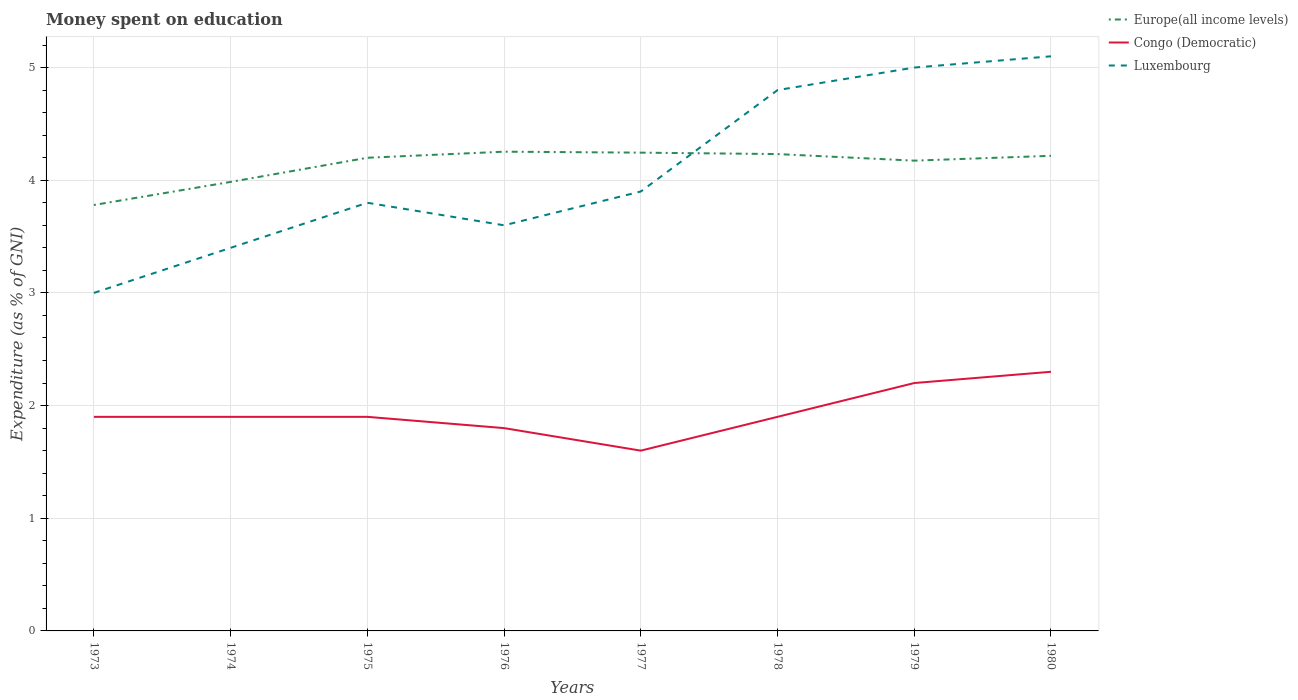Across all years, what is the maximum amount of money spent on education in Europe(all income levels)?
Provide a short and direct response. 3.78. What is the total amount of money spent on education in Congo (Democratic) in the graph?
Make the answer very short. -0.1. What is the difference between the highest and the second highest amount of money spent on education in Luxembourg?
Give a very brief answer. 2.1. Is the amount of money spent on education in Congo (Democratic) strictly greater than the amount of money spent on education in Europe(all income levels) over the years?
Offer a very short reply. Yes. How many years are there in the graph?
Your answer should be compact. 8. What is the difference between two consecutive major ticks on the Y-axis?
Your response must be concise. 1. Does the graph contain grids?
Your response must be concise. Yes. Where does the legend appear in the graph?
Your answer should be compact. Top right. How many legend labels are there?
Your response must be concise. 3. How are the legend labels stacked?
Your answer should be very brief. Vertical. What is the title of the graph?
Your answer should be very brief. Money spent on education. What is the label or title of the Y-axis?
Offer a terse response. Expenditure (as % of GNI). What is the Expenditure (as % of GNI) of Europe(all income levels) in 1973?
Provide a succinct answer. 3.78. What is the Expenditure (as % of GNI) in Luxembourg in 1973?
Provide a succinct answer. 3. What is the Expenditure (as % of GNI) of Europe(all income levels) in 1974?
Offer a very short reply. 3.99. What is the Expenditure (as % of GNI) in Congo (Democratic) in 1974?
Give a very brief answer. 1.9. What is the Expenditure (as % of GNI) of Luxembourg in 1974?
Provide a succinct answer. 3.4. What is the Expenditure (as % of GNI) in Europe(all income levels) in 1975?
Offer a very short reply. 4.2. What is the Expenditure (as % of GNI) in Congo (Democratic) in 1975?
Ensure brevity in your answer.  1.9. What is the Expenditure (as % of GNI) of Europe(all income levels) in 1976?
Offer a very short reply. 4.25. What is the Expenditure (as % of GNI) of Luxembourg in 1976?
Give a very brief answer. 3.6. What is the Expenditure (as % of GNI) of Europe(all income levels) in 1977?
Your response must be concise. 4.24. What is the Expenditure (as % of GNI) of Congo (Democratic) in 1977?
Your response must be concise. 1.6. What is the Expenditure (as % of GNI) in Luxembourg in 1977?
Offer a very short reply. 3.9. What is the Expenditure (as % of GNI) of Europe(all income levels) in 1978?
Offer a very short reply. 4.23. What is the Expenditure (as % of GNI) of Congo (Democratic) in 1978?
Offer a very short reply. 1.9. What is the Expenditure (as % of GNI) in Luxembourg in 1978?
Offer a very short reply. 4.8. What is the Expenditure (as % of GNI) of Europe(all income levels) in 1979?
Your response must be concise. 4.17. What is the Expenditure (as % of GNI) of Congo (Democratic) in 1979?
Make the answer very short. 2.2. What is the Expenditure (as % of GNI) of Europe(all income levels) in 1980?
Your response must be concise. 4.22. What is the Expenditure (as % of GNI) of Luxembourg in 1980?
Provide a succinct answer. 5.1. Across all years, what is the maximum Expenditure (as % of GNI) of Europe(all income levels)?
Make the answer very short. 4.25. Across all years, what is the minimum Expenditure (as % of GNI) of Europe(all income levels)?
Your answer should be very brief. 3.78. Across all years, what is the minimum Expenditure (as % of GNI) of Congo (Democratic)?
Offer a terse response. 1.6. Across all years, what is the minimum Expenditure (as % of GNI) of Luxembourg?
Offer a terse response. 3. What is the total Expenditure (as % of GNI) of Europe(all income levels) in the graph?
Keep it short and to the point. 33.09. What is the total Expenditure (as % of GNI) of Congo (Democratic) in the graph?
Give a very brief answer. 15.5. What is the total Expenditure (as % of GNI) of Luxembourg in the graph?
Ensure brevity in your answer.  32.6. What is the difference between the Expenditure (as % of GNI) in Europe(all income levels) in 1973 and that in 1974?
Ensure brevity in your answer.  -0.2. What is the difference between the Expenditure (as % of GNI) of Congo (Democratic) in 1973 and that in 1974?
Your answer should be very brief. 0. What is the difference between the Expenditure (as % of GNI) in Europe(all income levels) in 1973 and that in 1975?
Keep it short and to the point. -0.42. What is the difference between the Expenditure (as % of GNI) of Congo (Democratic) in 1973 and that in 1975?
Your response must be concise. 0. What is the difference between the Expenditure (as % of GNI) in Europe(all income levels) in 1973 and that in 1976?
Ensure brevity in your answer.  -0.47. What is the difference between the Expenditure (as % of GNI) of Europe(all income levels) in 1973 and that in 1977?
Provide a short and direct response. -0.46. What is the difference between the Expenditure (as % of GNI) in Congo (Democratic) in 1973 and that in 1977?
Ensure brevity in your answer.  0.3. What is the difference between the Expenditure (as % of GNI) of Luxembourg in 1973 and that in 1977?
Provide a succinct answer. -0.9. What is the difference between the Expenditure (as % of GNI) of Europe(all income levels) in 1973 and that in 1978?
Your answer should be very brief. -0.45. What is the difference between the Expenditure (as % of GNI) in Congo (Democratic) in 1973 and that in 1978?
Your answer should be very brief. 0. What is the difference between the Expenditure (as % of GNI) of Europe(all income levels) in 1973 and that in 1979?
Your response must be concise. -0.39. What is the difference between the Expenditure (as % of GNI) of Luxembourg in 1973 and that in 1979?
Your answer should be compact. -2. What is the difference between the Expenditure (as % of GNI) in Europe(all income levels) in 1973 and that in 1980?
Your answer should be compact. -0.44. What is the difference between the Expenditure (as % of GNI) of Europe(all income levels) in 1974 and that in 1975?
Your response must be concise. -0.21. What is the difference between the Expenditure (as % of GNI) of Congo (Democratic) in 1974 and that in 1975?
Provide a succinct answer. 0. What is the difference between the Expenditure (as % of GNI) in Europe(all income levels) in 1974 and that in 1976?
Provide a short and direct response. -0.27. What is the difference between the Expenditure (as % of GNI) in Congo (Democratic) in 1974 and that in 1976?
Keep it short and to the point. 0.1. What is the difference between the Expenditure (as % of GNI) of Luxembourg in 1974 and that in 1976?
Offer a very short reply. -0.2. What is the difference between the Expenditure (as % of GNI) in Europe(all income levels) in 1974 and that in 1977?
Your answer should be very brief. -0.26. What is the difference between the Expenditure (as % of GNI) in Europe(all income levels) in 1974 and that in 1978?
Keep it short and to the point. -0.25. What is the difference between the Expenditure (as % of GNI) in Luxembourg in 1974 and that in 1978?
Provide a short and direct response. -1.4. What is the difference between the Expenditure (as % of GNI) in Europe(all income levels) in 1974 and that in 1979?
Offer a terse response. -0.19. What is the difference between the Expenditure (as % of GNI) of Congo (Democratic) in 1974 and that in 1979?
Provide a short and direct response. -0.3. What is the difference between the Expenditure (as % of GNI) of Luxembourg in 1974 and that in 1979?
Provide a short and direct response. -1.6. What is the difference between the Expenditure (as % of GNI) in Europe(all income levels) in 1974 and that in 1980?
Give a very brief answer. -0.23. What is the difference between the Expenditure (as % of GNI) of Luxembourg in 1974 and that in 1980?
Give a very brief answer. -1.7. What is the difference between the Expenditure (as % of GNI) of Europe(all income levels) in 1975 and that in 1976?
Provide a short and direct response. -0.05. What is the difference between the Expenditure (as % of GNI) of Congo (Democratic) in 1975 and that in 1976?
Make the answer very short. 0.1. What is the difference between the Expenditure (as % of GNI) in Luxembourg in 1975 and that in 1976?
Keep it short and to the point. 0.2. What is the difference between the Expenditure (as % of GNI) in Europe(all income levels) in 1975 and that in 1977?
Provide a short and direct response. -0.05. What is the difference between the Expenditure (as % of GNI) in Europe(all income levels) in 1975 and that in 1978?
Keep it short and to the point. -0.03. What is the difference between the Expenditure (as % of GNI) of Congo (Democratic) in 1975 and that in 1978?
Your answer should be compact. 0. What is the difference between the Expenditure (as % of GNI) in Luxembourg in 1975 and that in 1978?
Keep it short and to the point. -1. What is the difference between the Expenditure (as % of GNI) of Europe(all income levels) in 1975 and that in 1979?
Provide a short and direct response. 0.03. What is the difference between the Expenditure (as % of GNI) in Europe(all income levels) in 1975 and that in 1980?
Your response must be concise. -0.02. What is the difference between the Expenditure (as % of GNI) of Europe(all income levels) in 1976 and that in 1977?
Give a very brief answer. 0.01. What is the difference between the Expenditure (as % of GNI) in Luxembourg in 1976 and that in 1977?
Your answer should be compact. -0.3. What is the difference between the Expenditure (as % of GNI) in Europe(all income levels) in 1976 and that in 1978?
Offer a very short reply. 0.02. What is the difference between the Expenditure (as % of GNI) of Europe(all income levels) in 1976 and that in 1979?
Your answer should be very brief. 0.08. What is the difference between the Expenditure (as % of GNI) of Luxembourg in 1976 and that in 1979?
Provide a short and direct response. -1.4. What is the difference between the Expenditure (as % of GNI) in Europe(all income levels) in 1976 and that in 1980?
Offer a very short reply. 0.04. What is the difference between the Expenditure (as % of GNI) in Europe(all income levels) in 1977 and that in 1978?
Provide a succinct answer. 0.01. What is the difference between the Expenditure (as % of GNI) of Congo (Democratic) in 1977 and that in 1978?
Make the answer very short. -0.3. What is the difference between the Expenditure (as % of GNI) of Luxembourg in 1977 and that in 1978?
Ensure brevity in your answer.  -0.9. What is the difference between the Expenditure (as % of GNI) in Europe(all income levels) in 1977 and that in 1979?
Your answer should be compact. 0.07. What is the difference between the Expenditure (as % of GNI) of Congo (Democratic) in 1977 and that in 1979?
Provide a succinct answer. -0.6. What is the difference between the Expenditure (as % of GNI) in Luxembourg in 1977 and that in 1979?
Your response must be concise. -1.1. What is the difference between the Expenditure (as % of GNI) in Europe(all income levels) in 1977 and that in 1980?
Offer a terse response. 0.03. What is the difference between the Expenditure (as % of GNI) in Europe(all income levels) in 1978 and that in 1979?
Provide a succinct answer. 0.06. What is the difference between the Expenditure (as % of GNI) in Luxembourg in 1978 and that in 1979?
Your answer should be very brief. -0.2. What is the difference between the Expenditure (as % of GNI) in Europe(all income levels) in 1978 and that in 1980?
Provide a short and direct response. 0.02. What is the difference between the Expenditure (as % of GNI) in Europe(all income levels) in 1979 and that in 1980?
Your answer should be very brief. -0.04. What is the difference between the Expenditure (as % of GNI) in Luxembourg in 1979 and that in 1980?
Your response must be concise. -0.1. What is the difference between the Expenditure (as % of GNI) of Europe(all income levels) in 1973 and the Expenditure (as % of GNI) of Congo (Democratic) in 1974?
Make the answer very short. 1.88. What is the difference between the Expenditure (as % of GNI) of Europe(all income levels) in 1973 and the Expenditure (as % of GNI) of Luxembourg in 1974?
Ensure brevity in your answer.  0.38. What is the difference between the Expenditure (as % of GNI) in Congo (Democratic) in 1973 and the Expenditure (as % of GNI) in Luxembourg in 1974?
Offer a very short reply. -1.5. What is the difference between the Expenditure (as % of GNI) of Europe(all income levels) in 1973 and the Expenditure (as % of GNI) of Congo (Democratic) in 1975?
Offer a very short reply. 1.88. What is the difference between the Expenditure (as % of GNI) in Europe(all income levels) in 1973 and the Expenditure (as % of GNI) in Luxembourg in 1975?
Give a very brief answer. -0.02. What is the difference between the Expenditure (as % of GNI) of Europe(all income levels) in 1973 and the Expenditure (as % of GNI) of Congo (Democratic) in 1976?
Make the answer very short. 1.98. What is the difference between the Expenditure (as % of GNI) in Europe(all income levels) in 1973 and the Expenditure (as % of GNI) in Luxembourg in 1976?
Keep it short and to the point. 0.18. What is the difference between the Expenditure (as % of GNI) in Europe(all income levels) in 1973 and the Expenditure (as % of GNI) in Congo (Democratic) in 1977?
Your answer should be compact. 2.18. What is the difference between the Expenditure (as % of GNI) of Europe(all income levels) in 1973 and the Expenditure (as % of GNI) of Luxembourg in 1977?
Provide a short and direct response. -0.12. What is the difference between the Expenditure (as % of GNI) in Congo (Democratic) in 1973 and the Expenditure (as % of GNI) in Luxembourg in 1977?
Offer a very short reply. -2. What is the difference between the Expenditure (as % of GNI) of Europe(all income levels) in 1973 and the Expenditure (as % of GNI) of Congo (Democratic) in 1978?
Ensure brevity in your answer.  1.88. What is the difference between the Expenditure (as % of GNI) of Europe(all income levels) in 1973 and the Expenditure (as % of GNI) of Luxembourg in 1978?
Give a very brief answer. -1.02. What is the difference between the Expenditure (as % of GNI) in Europe(all income levels) in 1973 and the Expenditure (as % of GNI) in Congo (Democratic) in 1979?
Provide a short and direct response. 1.58. What is the difference between the Expenditure (as % of GNI) in Europe(all income levels) in 1973 and the Expenditure (as % of GNI) in Luxembourg in 1979?
Make the answer very short. -1.22. What is the difference between the Expenditure (as % of GNI) in Europe(all income levels) in 1973 and the Expenditure (as % of GNI) in Congo (Democratic) in 1980?
Your answer should be compact. 1.48. What is the difference between the Expenditure (as % of GNI) of Europe(all income levels) in 1973 and the Expenditure (as % of GNI) of Luxembourg in 1980?
Provide a succinct answer. -1.32. What is the difference between the Expenditure (as % of GNI) of Congo (Democratic) in 1973 and the Expenditure (as % of GNI) of Luxembourg in 1980?
Offer a very short reply. -3.2. What is the difference between the Expenditure (as % of GNI) of Europe(all income levels) in 1974 and the Expenditure (as % of GNI) of Congo (Democratic) in 1975?
Provide a succinct answer. 2.09. What is the difference between the Expenditure (as % of GNI) in Europe(all income levels) in 1974 and the Expenditure (as % of GNI) in Luxembourg in 1975?
Make the answer very short. 0.19. What is the difference between the Expenditure (as % of GNI) of Europe(all income levels) in 1974 and the Expenditure (as % of GNI) of Congo (Democratic) in 1976?
Offer a terse response. 2.19. What is the difference between the Expenditure (as % of GNI) in Europe(all income levels) in 1974 and the Expenditure (as % of GNI) in Luxembourg in 1976?
Ensure brevity in your answer.  0.39. What is the difference between the Expenditure (as % of GNI) of Congo (Democratic) in 1974 and the Expenditure (as % of GNI) of Luxembourg in 1976?
Give a very brief answer. -1.7. What is the difference between the Expenditure (as % of GNI) in Europe(all income levels) in 1974 and the Expenditure (as % of GNI) in Congo (Democratic) in 1977?
Give a very brief answer. 2.39. What is the difference between the Expenditure (as % of GNI) of Europe(all income levels) in 1974 and the Expenditure (as % of GNI) of Luxembourg in 1977?
Offer a very short reply. 0.09. What is the difference between the Expenditure (as % of GNI) of Europe(all income levels) in 1974 and the Expenditure (as % of GNI) of Congo (Democratic) in 1978?
Make the answer very short. 2.09. What is the difference between the Expenditure (as % of GNI) of Europe(all income levels) in 1974 and the Expenditure (as % of GNI) of Luxembourg in 1978?
Your answer should be compact. -0.81. What is the difference between the Expenditure (as % of GNI) in Europe(all income levels) in 1974 and the Expenditure (as % of GNI) in Congo (Democratic) in 1979?
Keep it short and to the point. 1.79. What is the difference between the Expenditure (as % of GNI) of Europe(all income levels) in 1974 and the Expenditure (as % of GNI) of Luxembourg in 1979?
Provide a succinct answer. -1.01. What is the difference between the Expenditure (as % of GNI) in Europe(all income levels) in 1974 and the Expenditure (as % of GNI) in Congo (Democratic) in 1980?
Your answer should be very brief. 1.69. What is the difference between the Expenditure (as % of GNI) in Europe(all income levels) in 1974 and the Expenditure (as % of GNI) in Luxembourg in 1980?
Offer a terse response. -1.11. What is the difference between the Expenditure (as % of GNI) in Europe(all income levels) in 1975 and the Expenditure (as % of GNI) in Congo (Democratic) in 1976?
Give a very brief answer. 2.4. What is the difference between the Expenditure (as % of GNI) in Europe(all income levels) in 1975 and the Expenditure (as % of GNI) in Luxembourg in 1976?
Keep it short and to the point. 0.6. What is the difference between the Expenditure (as % of GNI) of Congo (Democratic) in 1975 and the Expenditure (as % of GNI) of Luxembourg in 1976?
Ensure brevity in your answer.  -1.7. What is the difference between the Expenditure (as % of GNI) of Europe(all income levels) in 1975 and the Expenditure (as % of GNI) of Congo (Democratic) in 1977?
Ensure brevity in your answer.  2.6. What is the difference between the Expenditure (as % of GNI) of Europe(all income levels) in 1975 and the Expenditure (as % of GNI) of Luxembourg in 1977?
Your response must be concise. 0.3. What is the difference between the Expenditure (as % of GNI) in Congo (Democratic) in 1975 and the Expenditure (as % of GNI) in Luxembourg in 1977?
Provide a short and direct response. -2. What is the difference between the Expenditure (as % of GNI) of Europe(all income levels) in 1975 and the Expenditure (as % of GNI) of Congo (Democratic) in 1978?
Your response must be concise. 2.3. What is the difference between the Expenditure (as % of GNI) in Europe(all income levels) in 1975 and the Expenditure (as % of GNI) in Luxembourg in 1978?
Provide a short and direct response. -0.6. What is the difference between the Expenditure (as % of GNI) in Congo (Democratic) in 1975 and the Expenditure (as % of GNI) in Luxembourg in 1978?
Your answer should be very brief. -2.9. What is the difference between the Expenditure (as % of GNI) in Europe(all income levels) in 1975 and the Expenditure (as % of GNI) in Congo (Democratic) in 1979?
Provide a short and direct response. 2. What is the difference between the Expenditure (as % of GNI) of Europe(all income levels) in 1975 and the Expenditure (as % of GNI) of Luxembourg in 1979?
Ensure brevity in your answer.  -0.8. What is the difference between the Expenditure (as % of GNI) in Europe(all income levels) in 1975 and the Expenditure (as % of GNI) in Congo (Democratic) in 1980?
Give a very brief answer. 1.9. What is the difference between the Expenditure (as % of GNI) in Europe(all income levels) in 1975 and the Expenditure (as % of GNI) in Luxembourg in 1980?
Give a very brief answer. -0.9. What is the difference between the Expenditure (as % of GNI) in Congo (Democratic) in 1975 and the Expenditure (as % of GNI) in Luxembourg in 1980?
Give a very brief answer. -3.2. What is the difference between the Expenditure (as % of GNI) of Europe(all income levels) in 1976 and the Expenditure (as % of GNI) of Congo (Democratic) in 1977?
Provide a succinct answer. 2.65. What is the difference between the Expenditure (as % of GNI) in Europe(all income levels) in 1976 and the Expenditure (as % of GNI) in Luxembourg in 1977?
Give a very brief answer. 0.35. What is the difference between the Expenditure (as % of GNI) of Europe(all income levels) in 1976 and the Expenditure (as % of GNI) of Congo (Democratic) in 1978?
Make the answer very short. 2.35. What is the difference between the Expenditure (as % of GNI) in Europe(all income levels) in 1976 and the Expenditure (as % of GNI) in Luxembourg in 1978?
Your response must be concise. -0.55. What is the difference between the Expenditure (as % of GNI) in Europe(all income levels) in 1976 and the Expenditure (as % of GNI) in Congo (Democratic) in 1979?
Your response must be concise. 2.05. What is the difference between the Expenditure (as % of GNI) in Europe(all income levels) in 1976 and the Expenditure (as % of GNI) in Luxembourg in 1979?
Provide a short and direct response. -0.75. What is the difference between the Expenditure (as % of GNI) in Congo (Democratic) in 1976 and the Expenditure (as % of GNI) in Luxembourg in 1979?
Your answer should be very brief. -3.2. What is the difference between the Expenditure (as % of GNI) of Europe(all income levels) in 1976 and the Expenditure (as % of GNI) of Congo (Democratic) in 1980?
Offer a very short reply. 1.95. What is the difference between the Expenditure (as % of GNI) in Europe(all income levels) in 1976 and the Expenditure (as % of GNI) in Luxembourg in 1980?
Keep it short and to the point. -0.85. What is the difference between the Expenditure (as % of GNI) in Congo (Democratic) in 1976 and the Expenditure (as % of GNI) in Luxembourg in 1980?
Your answer should be very brief. -3.3. What is the difference between the Expenditure (as % of GNI) of Europe(all income levels) in 1977 and the Expenditure (as % of GNI) of Congo (Democratic) in 1978?
Make the answer very short. 2.34. What is the difference between the Expenditure (as % of GNI) in Europe(all income levels) in 1977 and the Expenditure (as % of GNI) in Luxembourg in 1978?
Your response must be concise. -0.56. What is the difference between the Expenditure (as % of GNI) of Congo (Democratic) in 1977 and the Expenditure (as % of GNI) of Luxembourg in 1978?
Offer a terse response. -3.2. What is the difference between the Expenditure (as % of GNI) in Europe(all income levels) in 1977 and the Expenditure (as % of GNI) in Congo (Democratic) in 1979?
Offer a very short reply. 2.04. What is the difference between the Expenditure (as % of GNI) of Europe(all income levels) in 1977 and the Expenditure (as % of GNI) of Luxembourg in 1979?
Keep it short and to the point. -0.76. What is the difference between the Expenditure (as % of GNI) in Europe(all income levels) in 1977 and the Expenditure (as % of GNI) in Congo (Democratic) in 1980?
Make the answer very short. 1.94. What is the difference between the Expenditure (as % of GNI) in Europe(all income levels) in 1977 and the Expenditure (as % of GNI) in Luxembourg in 1980?
Your answer should be very brief. -0.86. What is the difference between the Expenditure (as % of GNI) of Europe(all income levels) in 1978 and the Expenditure (as % of GNI) of Congo (Democratic) in 1979?
Ensure brevity in your answer.  2.03. What is the difference between the Expenditure (as % of GNI) in Europe(all income levels) in 1978 and the Expenditure (as % of GNI) in Luxembourg in 1979?
Offer a terse response. -0.77. What is the difference between the Expenditure (as % of GNI) of Europe(all income levels) in 1978 and the Expenditure (as % of GNI) of Congo (Democratic) in 1980?
Offer a terse response. 1.93. What is the difference between the Expenditure (as % of GNI) in Europe(all income levels) in 1978 and the Expenditure (as % of GNI) in Luxembourg in 1980?
Give a very brief answer. -0.87. What is the difference between the Expenditure (as % of GNI) in Europe(all income levels) in 1979 and the Expenditure (as % of GNI) in Congo (Democratic) in 1980?
Offer a terse response. 1.87. What is the difference between the Expenditure (as % of GNI) in Europe(all income levels) in 1979 and the Expenditure (as % of GNI) in Luxembourg in 1980?
Give a very brief answer. -0.93. What is the difference between the Expenditure (as % of GNI) of Congo (Democratic) in 1979 and the Expenditure (as % of GNI) of Luxembourg in 1980?
Your answer should be very brief. -2.9. What is the average Expenditure (as % of GNI) of Europe(all income levels) per year?
Make the answer very short. 4.14. What is the average Expenditure (as % of GNI) of Congo (Democratic) per year?
Keep it short and to the point. 1.94. What is the average Expenditure (as % of GNI) in Luxembourg per year?
Ensure brevity in your answer.  4.08. In the year 1973, what is the difference between the Expenditure (as % of GNI) of Europe(all income levels) and Expenditure (as % of GNI) of Congo (Democratic)?
Provide a succinct answer. 1.88. In the year 1973, what is the difference between the Expenditure (as % of GNI) of Europe(all income levels) and Expenditure (as % of GNI) of Luxembourg?
Make the answer very short. 0.78. In the year 1974, what is the difference between the Expenditure (as % of GNI) in Europe(all income levels) and Expenditure (as % of GNI) in Congo (Democratic)?
Your response must be concise. 2.09. In the year 1974, what is the difference between the Expenditure (as % of GNI) of Europe(all income levels) and Expenditure (as % of GNI) of Luxembourg?
Provide a succinct answer. 0.59. In the year 1974, what is the difference between the Expenditure (as % of GNI) of Congo (Democratic) and Expenditure (as % of GNI) of Luxembourg?
Your response must be concise. -1.5. In the year 1975, what is the difference between the Expenditure (as % of GNI) of Europe(all income levels) and Expenditure (as % of GNI) of Congo (Democratic)?
Provide a succinct answer. 2.3. In the year 1975, what is the difference between the Expenditure (as % of GNI) of Europe(all income levels) and Expenditure (as % of GNI) of Luxembourg?
Keep it short and to the point. 0.4. In the year 1976, what is the difference between the Expenditure (as % of GNI) of Europe(all income levels) and Expenditure (as % of GNI) of Congo (Democratic)?
Provide a succinct answer. 2.45. In the year 1976, what is the difference between the Expenditure (as % of GNI) of Europe(all income levels) and Expenditure (as % of GNI) of Luxembourg?
Keep it short and to the point. 0.65. In the year 1977, what is the difference between the Expenditure (as % of GNI) in Europe(all income levels) and Expenditure (as % of GNI) in Congo (Democratic)?
Your answer should be compact. 2.64. In the year 1977, what is the difference between the Expenditure (as % of GNI) of Europe(all income levels) and Expenditure (as % of GNI) of Luxembourg?
Provide a short and direct response. 0.34. In the year 1977, what is the difference between the Expenditure (as % of GNI) in Congo (Democratic) and Expenditure (as % of GNI) in Luxembourg?
Provide a short and direct response. -2.3. In the year 1978, what is the difference between the Expenditure (as % of GNI) in Europe(all income levels) and Expenditure (as % of GNI) in Congo (Democratic)?
Make the answer very short. 2.33. In the year 1978, what is the difference between the Expenditure (as % of GNI) in Europe(all income levels) and Expenditure (as % of GNI) in Luxembourg?
Your answer should be very brief. -0.57. In the year 1978, what is the difference between the Expenditure (as % of GNI) in Congo (Democratic) and Expenditure (as % of GNI) in Luxembourg?
Offer a very short reply. -2.9. In the year 1979, what is the difference between the Expenditure (as % of GNI) of Europe(all income levels) and Expenditure (as % of GNI) of Congo (Democratic)?
Your response must be concise. 1.97. In the year 1979, what is the difference between the Expenditure (as % of GNI) in Europe(all income levels) and Expenditure (as % of GNI) in Luxembourg?
Offer a terse response. -0.83. In the year 1980, what is the difference between the Expenditure (as % of GNI) of Europe(all income levels) and Expenditure (as % of GNI) of Congo (Democratic)?
Ensure brevity in your answer.  1.92. In the year 1980, what is the difference between the Expenditure (as % of GNI) of Europe(all income levels) and Expenditure (as % of GNI) of Luxembourg?
Provide a short and direct response. -0.88. In the year 1980, what is the difference between the Expenditure (as % of GNI) in Congo (Democratic) and Expenditure (as % of GNI) in Luxembourg?
Provide a short and direct response. -2.8. What is the ratio of the Expenditure (as % of GNI) in Europe(all income levels) in 1973 to that in 1974?
Offer a very short reply. 0.95. What is the ratio of the Expenditure (as % of GNI) in Congo (Democratic) in 1973 to that in 1974?
Give a very brief answer. 1. What is the ratio of the Expenditure (as % of GNI) of Luxembourg in 1973 to that in 1974?
Offer a terse response. 0.88. What is the ratio of the Expenditure (as % of GNI) of Europe(all income levels) in 1973 to that in 1975?
Ensure brevity in your answer.  0.9. What is the ratio of the Expenditure (as % of GNI) in Luxembourg in 1973 to that in 1975?
Your response must be concise. 0.79. What is the ratio of the Expenditure (as % of GNI) in Europe(all income levels) in 1973 to that in 1976?
Your response must be concise. 0.89. What is the ratio of the Expenditure (as % of GNI) of Congo (Democratic) in 1973 to that in 1976?
Provide a succinct answer. 1.06. What is the ratio of the Expenditure (as % of GNI) in Europe(all income levels) in 1973 to that in 1977?
Give a very brief answer. 0.89. What is the ratio of the Expenditure (as % of GNI) of Congo (Democratic) in 1973 to that in 1977?
Make the answer very short. 1.19. What is the ratio of the Expenditure (as % of GNI) of Luxembourg in 1973 to that in 1977?
Make the answer very short. 0.77. What is the ratio of the Expenditure (as % of GNI) in Europe(all income levels) in 1973 to that in 1978?
Offer a terse response. 0.89. What is the ratio of the Expenditure (as % of GNI) of Congo (Democratic) in 1973 to that in 1978?
Your answer should be compact. 1. What is the ratio of the Expenditure (as % of GNI) of Luxembourg in 1973 to that in 1978?
Keep it short and to the point. 0.62. What is the ratio of the Expenditure (as % of GNI) of Europe(all income levels) in 1973 to that in 1979?
Offer a very short reply. 0.91. What is the ratio of the Expenditure (as % of GNI) of Congo (Democratic) in 1973 to that in 1979?
Keep it short and to the point. 0.86. What is the ratio of the Expenditure (as % of GNI) of Europe(all income levels) in 1973 to that in 1980?
Provide a succinct answer. 0.9. What is the ratio of the Expenditure (as % of GNI) in Congo (Democratic) in 1973 to that in 1980?
Give a very brief answer. 0.83. What is the ratio of the Expenditure (as % of GNI) of Luxembourg in 1973 to that in 1980?
Make the answer very short. 0.59. What is the ratio of the Expenditure (as % of GNI) of Europe(all income levels) in 1974 to that in 1975?
Provide a succinct answer. 0.95. What is the ratio of the Expenditure (as % of GNI) in Luxembourg in 1974 to that in 1975?
Ensure brevity in your answer.  0.89. What is the ratio of the Expenditure (as % of GNI) of Europe(all income levels) in 1974 to that in 1976?
Your answer should be compact. 0.94. What is the ratio of the Expenditure (as % of GNI) of Congo (Democratic) in 1974 to that in 1976?
Offer a very short reply. 1.06. What is the ratio of the Expenditure (as % of GNI) of Luxembourg in 1974 to that in 1976?
Your answer should be compact. 0.94. What is the ratio of the Expenditure (as % of GNI) of Europe(all income levels) in 1974 to that in 1977?
Provide a succinct answer. 0.94. What is the ratio of the Expenditure (as % of GNI) of Congo (Democratic) in 1974 to that in 1977?
Keep it short and to the point. 1.19. What is the ratio of the Expenditure (as % of GNI) in Luxembourg in 1974 to that in 1977?
Your answer should be compact. 0.87. What is the ratio of the Expenditure (as % of GNI) in Europe(all income levels) in 1974 to that in 1978?
Ensure brevity in your answer.  0.94. What is the ratio of the Expenditure (as % of GNI) in Luxembourg in 1974 to that in 1978?
Give a very brief answer. 0.71. What is the ratio of the Expenditure (as % of GNI) in Europe(all income levels) in 1974 to that in 1979?
Keep it short and to the point. 0.95. What is the ratio of the Expenditure (as % of GNI) of Congo (Democratic) in 1974 to that in 1979?
Offer a very short reply. 0.86. What is the ratio of the Expenditure (as % of GNI) of Luxembourg in 1974 to that in 1979?
Your answer should be compact. 0.68. What is the ratio of the Expenditure (as % of GNI) in Europe(all income levels) in 1974 to that in 1980?
Give a very brief answer. 0.94. What is the ratio of the Expenditure (as % of GNI) in Congo (Democratic) in 1974 to that in 1980?
Your answer should be compact. 0.83. What is the ratio of the Expenditure (as % of GNI) in Luxembourg in 1974 to that in 1980?
Keep it short and to the point. 0.67. What is the ratio of the Expenditure (as % of GNI) of Europe(all income levels) in 1975 to that in 1976?
Ensure brevity in your answer.  0.99. What is the ratio of the Expenditure (as % of GNI) of Congo (Democratic) in 1975 to that in 1976?
Your answer should be very brief. 1.06. What is the ratio of the Expenditure (as % of GNI) in Luxembourg in 1975 to that in 1976?
Make the answer very short. 1.06. What is the ratio of the Expenditure (as % of GNI) in Europe(all income levels) in 1975 to that in 1977?
Offer a terse response. 0.99. What is the ratio of the Expenditure (as % of GNI) in Congo (Democratic) in 1975 to that in 1977?
Your answer should be very brief. 1.19. What is the ratio of the Expenditure (as % of GNI) in Luxembourg in 1975 to that in 1977?
Offer a very short reply. 0.97. What is the ratio of the Expenditure (as % of GNI) of Luxembourg in 1975 to that in 1978?
Make the answer very short. 0.79. What is the ratio of the Expenditure (as % of GNI) of Europe(all income levels) in 1975 to that in 1979?
Provide a short and direct response. 1.01. What is the ratio of the Expenditure (as % of GNI) of Congo (Democratic) in 1975 to that in 1979?
Your answer should be very brief. 0.86. What is the ratio of the Expenditure (as % of GNI) in Luxembourg in 1975 to that in 1979?
Keep it short and to the point. 0.76. What is the ratio of the Expenditure (as % of GNI) in Congo (Democratic) in 1975 to that in 1980?
Offer a very short reply. 0.83. What is the ratio of the Expenditure (as % of GNI) of Luxembourg in 1975 to that in 1980?
Offer a terse response. 0.75. What is the ratio of the Expenditure (as % of GNI) in Europe(all income levels) in 1976 to that in 1977?
Your answer should be compact. 1. What is the ratio of the Expenditure (as % of GNI) of Congo (Democratic) in 1976 to that in 1977?
Your response must be concise. 1.12. What is the ratio of the Expenditure (as % of GNI) in Europe(all income levels) in 1976 to that in 1978?
Provide a short and direct response. 1. What is the ratio of the Expenditure (as % of GNI) of Luxembourg in 1976 to that in 1978?
Provide a short and direct response. 0.75. What is the ratio of the Expenditure (as % of GNI) of Europe(all income levels) in 1976 to that in 1979?
Your answer should be very brief. 1.02. What is the ratio of the Expenditure (as % of GNI) of Congo (Democratic) in 1976 to that in 1979?
Make the answer very short. 0.82. What is the ratio of the Expenditure (as % of GNI) of Luxembourg in 1976 to that in 1979?
Keep it short and to the point. 0.72. What is the ratio of the Expenditure (as % of GNI) in Europe(all income levels) in 1976 to that in 1980?
Give a very brief answer. 1.01. What is the ratio of the Expenditure (as % of GNI) in Congo (Democratic) in 1976 to that in 1980?
Your answer should be compact. 0.78. What is the ratio of the Expenditure (as % of GNI) in Luxembourg in 1976 to that in 1980?
Your response must be concise. 0.71. What is the ratio of the Expenditure (as % of GNI) of Congo (Democratic) in 1977 to that in 1978?
Make the answer very short. 0.84. What is the ratio of the Expenditure (as % of GNI) in Luxembourg in 1977 to that in 1978?
Offer a terse response. 0.81. What is the ratio of the Expenditure (as % of GNI) of Europe(all income levels) in 1977 to that in 1979?
Provide a short and direct response. 1.02. What is the ratio of the Expenditure (as % of GNI) in Congo (Democratic) in 1977 to that in 1979?
Give a very brief answer. 0.73. What is the ratio of the Expenditure (as % of GNI) in Luxembourg in 1977 to that in 1979?
Keep it short and to the point. 0.78. What is the ratio of the Expenditure (as % of GNI) of Europe(all income levels) in 1977 to that in 1980?
Your answer should be very brief. 1.01. What is the ratio of the Expenditure (as % of GNI) of Congo (Democratic) in 1977 to that in 1980?
Your answer should be compact. 0.7. What is the ratio of the Expenditure (as % of GNI) of Luxembourg in 1977 to that in 1980?
Provide a short and direct response. 0.76. What is the ratio of the Expenditure (as % of GNI) of Europe(all income levels) in 1978 to that in 1979?
Offer a very short reply. 1.01. What is the ratio of the Expenditure (as % of GNI) in Congo (Democratic) in 1978 to that in 1979?
Offer a terse response. 0.86. What is the ratio of the Expenditure (as % of GNI) in Luxembourg in 1978 to that in 1979?
Offer a very short reply. 0.96. What is the ratio of the Expenditure (as % of GNI) in Europe(all income levels) in 1978 to that in 1980?
Make the answer very short. 1. What is the ratio of the Expenditure (as % of GNI) of Congo (Democratic) in 1978 to that in 1980?
Ensure brevity in your answer.  0.83. What is the ratio of the Expenditure (as % of GNI) in Europe(all income levels) in 1979 to that in 1980?
Provide a short and direct response. 0.99. What is the ratio of the Expenditure (as % of GNI) of Congo (Democratic) in 1979 to that in 1980?
Offer a very short reply. 0.96. What is the ratio of the Expenditure (as % of GNI) in Luxembourg in 1979 to that in 1980?
Provide a short and direct response. 0.98. What is the difference between the highest and the second highest Expenditure (as % of GNI) in Europe(all income levels)?
Ensure brevity in your answer.  0.01. What is the difference between the highest and the second highest Expenditure (as % of GNI) in Luxembourg?
Ensure brevity in your answer.  0.1. What is the difference between the highest and the lowest Expenditure (as % of GNI) in Europe(all income levels)?
Give a very brief answer. 0.47. 